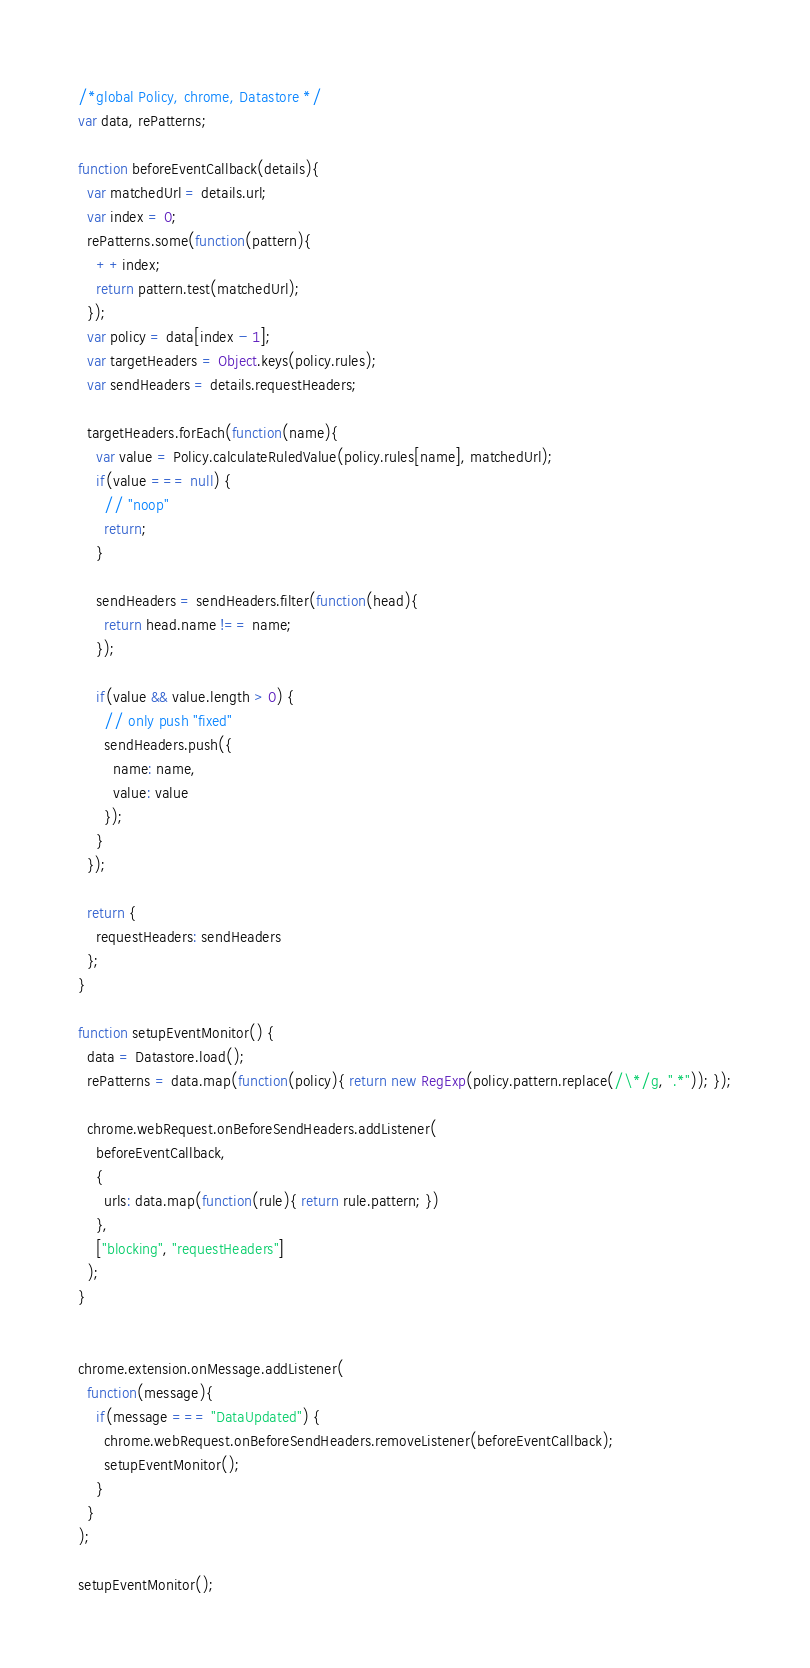Convert code to text. <code><loc_0><loc_0><loc_500><loc_500><_JavaScript_>/*global Policy, chrome, Datastore */
var data, rePatterns;

function beforeEventCallback(details){
  var matchedUrl = details.url;
  var index = 0;
  rePatterns.some(function(pattern){
    ++index;
    return pattern.test(matchedUrl);
  });
  var policy = data[index - 1];
  var targetHeaders = Object.keys(policy.rules);
  var sendHeaders = details.requestHeaders;

  targetHeaders.forEach(function(name){
    var value = Policy.calculateRuledValue(policy.rules[name], matchedUrl);
    if(value === null) {
      // "noop"
      return;
    }

    sendHeaders = sendHeaders.filter(function(head){
      return head.name !== name;
    });

    if(value && value.length > 0) {
      // only push "fixed"
      sendHeaders.push({
        name: name,
        value: value
      });
    }
  });

  return {
    requestHeaders: sendHeaders
  };
}

function setupEventMonitor() {
  data = Datastore.load();
  rePatterns = data.map(function(policy){ return new RegExp(policy.pattern.replace(/\*/g, ".*")); });

  chrome.webRequest.onBeforeSendHeaders.addListener(
    beforeEventCallback,
    {
      urls: data.map(function(rule){ return rule.pattern; })
    },
    ["blocking", "requestHeaders"]
  );
}


chrome.extension.onMessage.addListener(
  function(message){
    if(message === "DataUpdated") {
      chrome.webRequest.onBeforeSendHeaders.removeListener(beforeEventCallback);
      setupEventMonitor();
    }
  }
);

setupEventMonitor();
</code> 